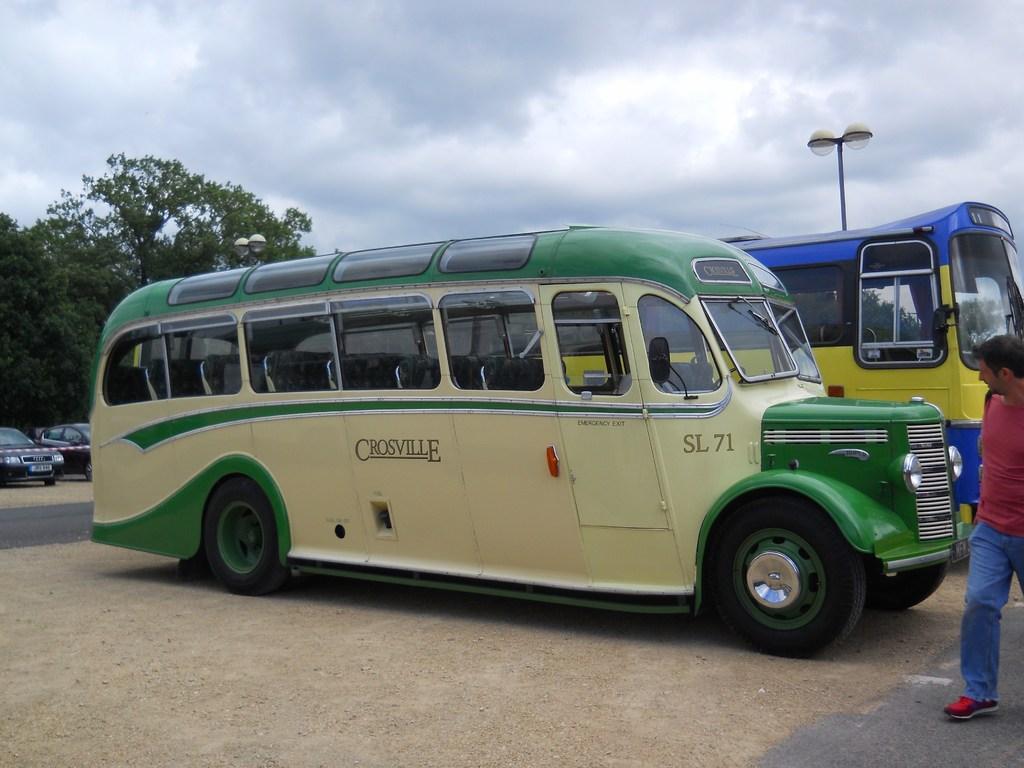Can you describe this image briefly? In this image there are a few vehicles on the road and there is a person walking. In the background there are trees, a pole and the sky. 